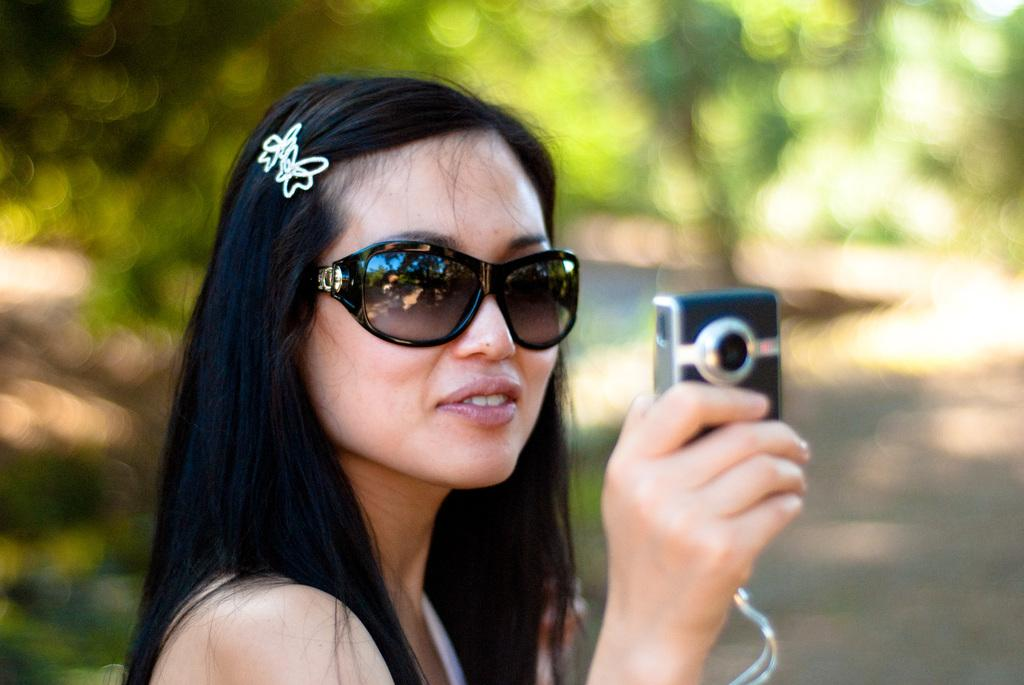What is the main subject of the picture? The main subject of the picture is a woman. What is the woman holding in the picture? The woman is holding a camera. Can you describe the woman's attire in the picture? The woman is wearing a white dress and black spectacles. How would you describe the background of the image? The background of the image is edited. What type of locket can be seen hanging from the woman's neck in the image? There is no locket visible in the image; the woman is wearing a white dress and black spectacles, but no jewelry is mentioned. 